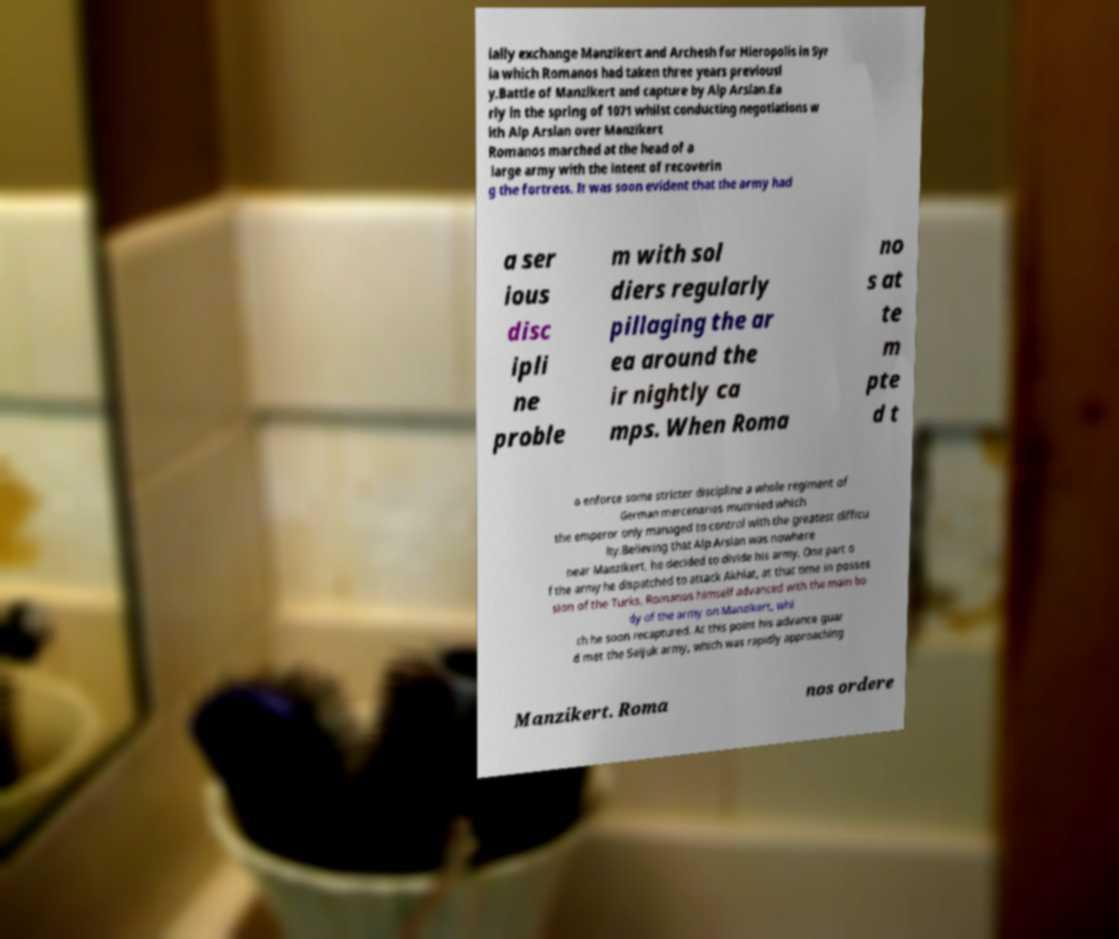Can you accurately transcribe the text from the provided image for me? ially exchange Manzikert and Archesh for Hieropolis in Syr ia which Romanos had taken three years previousl y.Battle of Manzikert and capture by Alp Arslan.Ea rly in the spring of 1071 whilst conducting negotiations w ith Alp Arslan over Manzikert Romanos marched at the head of a large army with the intent of recoverin g the fortress. It was soon evident that the army had a ser ious disc ipli ne proble m with sol diers regularly pillaging the ar ea around the ir nightly ca mps. When Roma no s at te m pte d t o enforce some stricter discipline a whole regiment of German mercenaries mutinied which the emperor only managed to control with the greatest difficu lty.Believing that Alp Arslan was nowhere near Manzikert, he decided to divide his army. One part o f the army he dispatched to attack Akhlat, at that time in posses sion of the Turks. Romanos himself advanced with the main bo dy of the army on Manzikert, whi ch he soon recaptured. At this point his advance guar d met the Seljuk army, which was rapidly approaching Manzikert. Roma nos ordere 